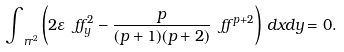Convert formula to latex. <formula><loc_0><loc_0><loc_500><loc_500>\int _ { \ r r ^ { 2 } } \left ( 2 \varepsilon \ f f _ { y } ^ { 2 } - \frac { p } { ( p + 1 ) ( p + 2 ) } \ f f ^ { p + 2 } \right ) \, d x d y = 0 .</formula> 